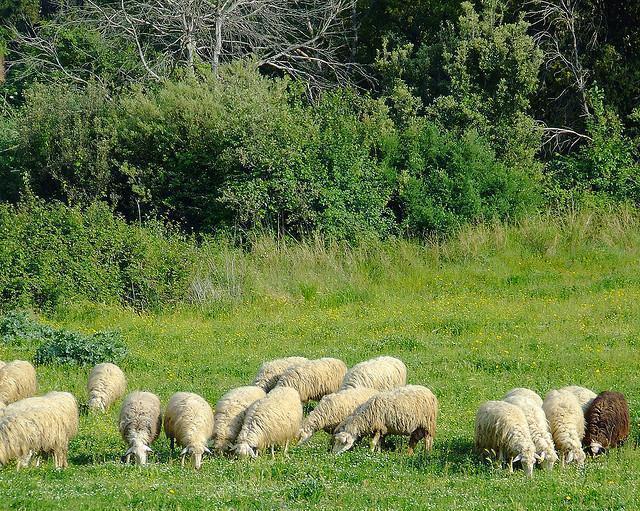These animals have an average lifespan of how many years?
Choose the right answer and clarify with the format: 'Answer: answer
Rationale: rationale.'
Options: Thirty, twelve, five, forty. Answer: twelve.
Rationale: Sheep live for twelve years. 